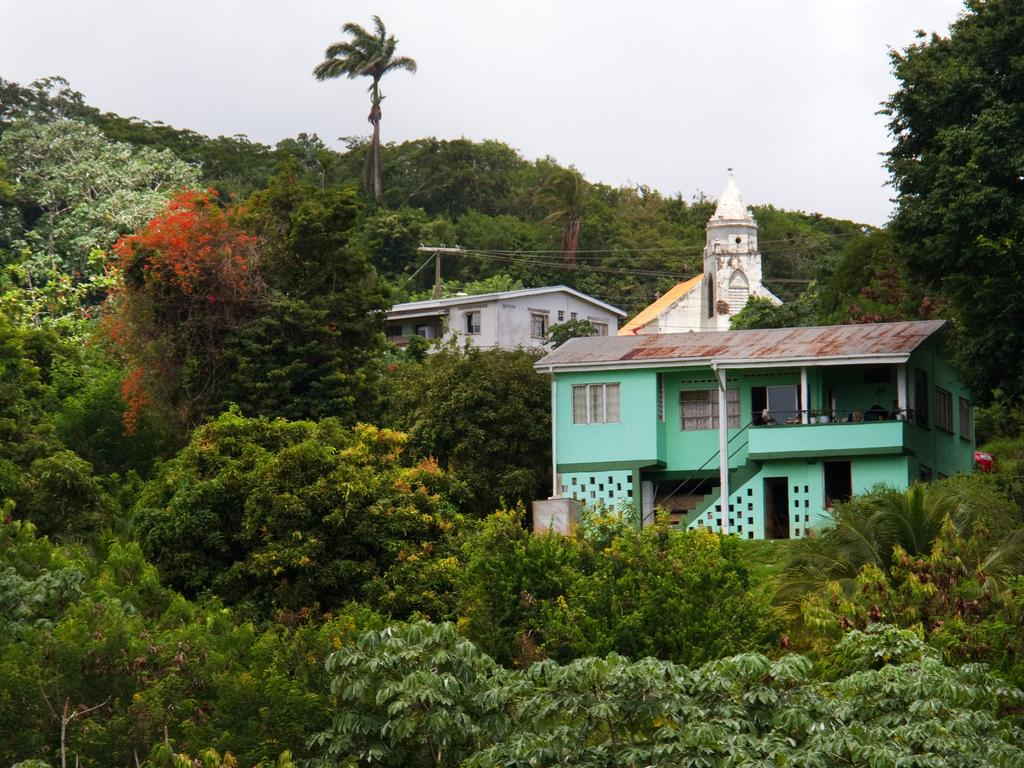What structures are present in the image? There are buildings in the image. What is the surrounding environment of the buildings? The buildings are surrounded by huge trees. What can be seen in the background of the image? There is a sky visible in the background of the image. Which famous actor can be seen standing next to the buildings in the image? There is no actor present in the image; it only features buildings and trees. Is there a volcano visible in the image? No, there is no volcano present in the image. 